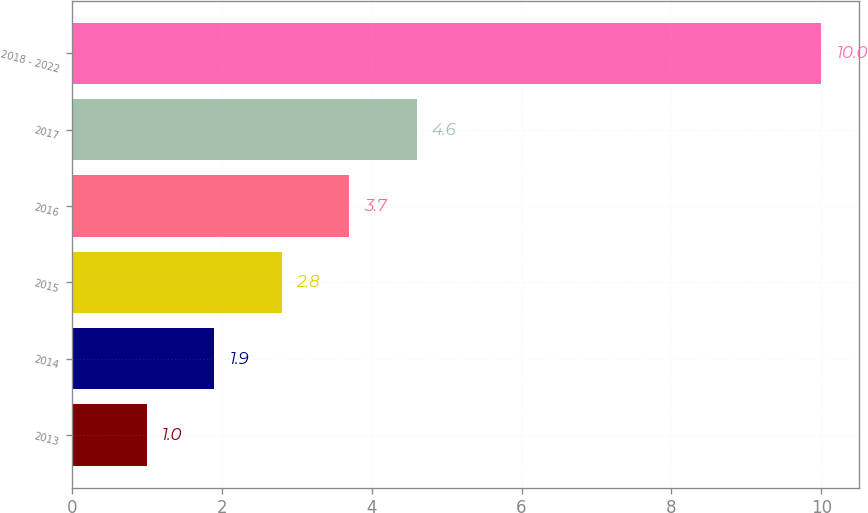<chart> <loc_0><loc_0><loc_500><loc_500><bar_chart><fcel>2013<fcel>2014<fcel>2015<fcel>2016<fcel>2017<fcel>2018 - 2022<nl><fcel>1<fcel>1.9<fcel>2.8<fcel>3.7<fcel>4.6<fcel>10<nl></chart> 